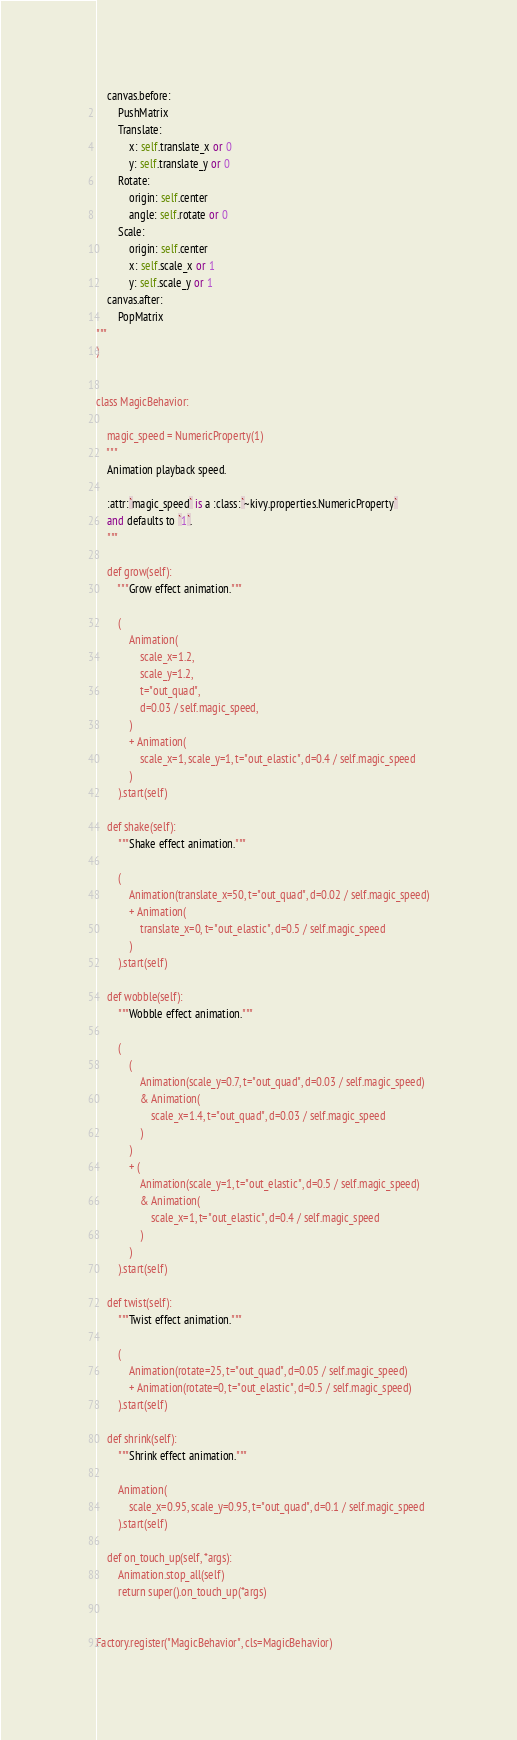Convert code to text. <code><loc_0><loc_0><loc_500><loc_500><_Python_>
    canvas.before:
        PushMatrix
        Translate:
            x: self.translate_x or 0
            y: self.translate_y or 0
        Rotate:
            origin: self.center
            angle: self.rotate or 0
        Scale:
            origin: self.center
            x: self.scale_x or 1
            y: self.scale_y or 1
    canvas.after:
        PopMatrix
"""
)


class MagicBehavior:

    magic_speed = NumericProperty(1)
    """
    Animation playback speed.

    :attr:`magic_speed` is a :class:`~kivy.properties.NumericProperty`
    and defaults to `1`.
    """

    def grow(self):
        """Grow effect animation."""

        (
            Animation(
                scale_x=1.2,
                scale_y=1.2,
                t="out_quad",
                d=0.03 / self.magic_speed,
            )
            + Animation(
                scale_x=1, scale_y=1, t="out_elastic", d=0.4 / self.magic_speed
            )
        ).start(self)

    def shake(self):
        """Shake effect animation."""

        (
            Animation(translate_x=50, t="out_quad", d=0.02 / self.magic_speed)
            + Animation(
                translate_x=0, t="out_elastic", d=0.5 / self.magic_speed
            )
        ).start(self)

    def wobble(self):
        """Wobble effect animation."""

        (
            (
                Animation(scale_y=0.7, t="out_quad", d=0.03 / self.magic_speed)
                & Animation(
                    scale_x=1.4, t="out_quad", d=0.03 / self.magic_speed
                )
            )
            + (
                Animation(scale_y=1, t="out_elastic", d=0.5 / self.magic_speed)
                & Animation(
                    scale_x=1, t="out_elastic", d=0.4 / self.magic_speed
                )
            )
        ).start(self)

    def twist(self):
        """Twist effect animation."""

        (
            Animation(rotate=25, t="out_quad", d=0.05 / self.magic_speed)
            + Animation(rotate=0, t="out_elastic", d=0.5 / self.magic_speed)
        ).start(self)

    def shrink(self):
        """Shrink effect animation."""

        Animation(
            scale_x=0.95, scale_y=0.95, t="out_quad", d=0.1 / self.magic_speed
        ).start(self)

    def on_touch_up(self, *args):
        Animation.stop_all(self)
        return super().on_touch_up(*args)


Factory.register("MagicBehavior", cls=MagicBehavior)
</code> 